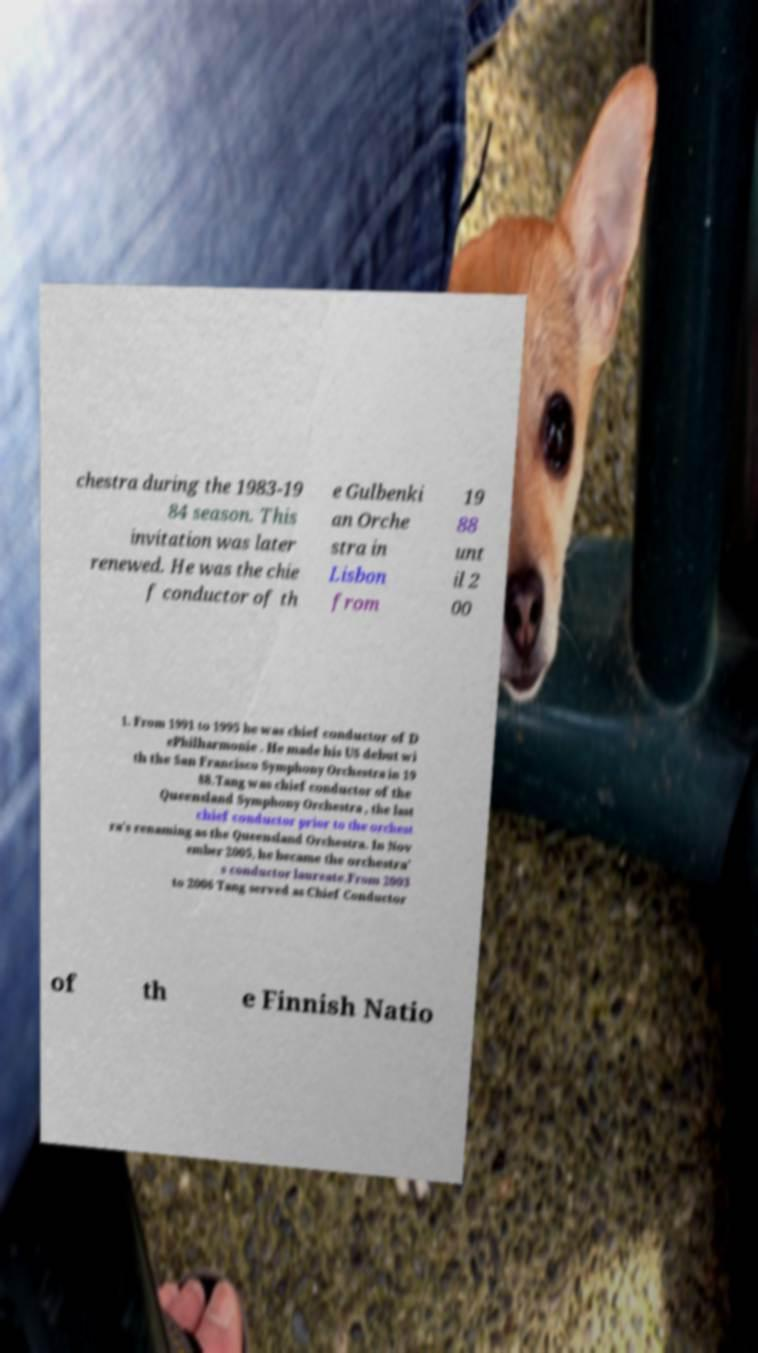Can you read and provide the text displayed in the image?This photo seems to have some interesting text. Can you extract and type it out for me? chestra during the 1983-19 84 season. This invitation was later renewed. He was the chie f conductor of th e Gulbenki an Orche stra in Lisbon from 19 88 unt il 2 00 1. From 1991 to 1995 he was chief conductor of D ePhilharmonie . He made his US debut wi th the San Francisco Symphony Orchestra in 19 88.Tang was chief conductor of the Queensland Symphony Orchestra , the last chief conductor prior to the orchest ra's renaming as the Queensland Orchestra. In Nov ember 2005, he became the orchestra' s conductor laureate.From 2003 to 2006 Tang served as Chief Conductor of th e Finnish Natio 